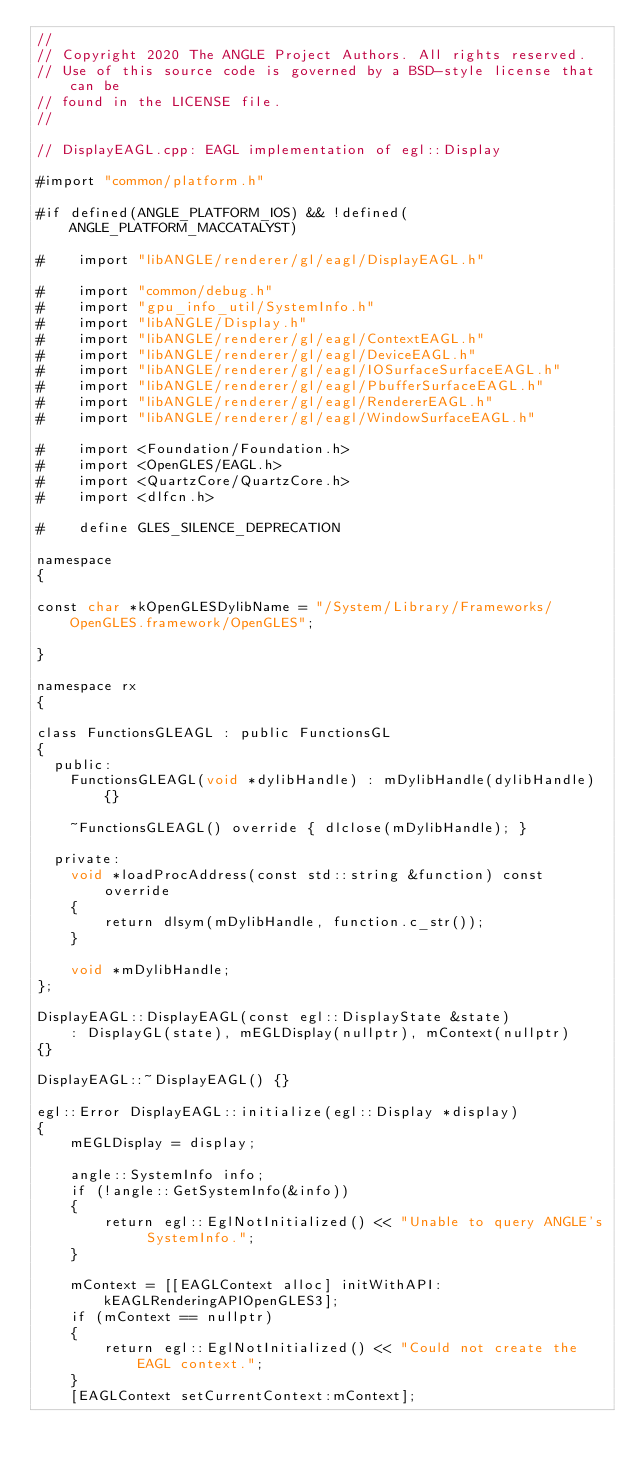<code> <loc_0><loc_0><loc_500><loc_500><_ObjectiveC_>//
// Copyright 2020 The ANGLE Project Authors. All rights reserved.
// Use of this source code is governed by a BSD-style license that can be
// found in the LICENSE file.
//

// DisplayEAGL.cpp: EAGL implementation of egl::Display

#import "common/platform.h"

#if defined(ANGLE_PLATFORM_IOS) && !defined(ANGLE_PLATFORM_MACCATALYST)

#    import "libANGLE/renderer/gl/eagl/DisplayEAGL.h"

#    import "common/debug.h"
#    import "gpu_info_util/SystemInfo.h"
#    import "libANGLE/Display.h"
#    import "libANGLE/renderer/gl/eagl/ContextEAGL.h"
#    import "libANGLE/renderer/gl/eagl/DeviceEAGL.h"
#    import "libANGLE/renderer/gl/eagl/IOSurfaceSurfaceEAGL.h"
#    import "libANGLE/renderer/gl/eagl/PbufferSurfaceEAGL.h"
#    import "libANGLE/renderer/gl/eagl/RendererEAGL.h"
#    import "libANGLE/renderer/gl/eagl/WindowSurfaceEAGL.h"

#    import <Foundation/Foundation.h>
#    import <OpenGLES/EAGL.h>
#    import <QuartzCore/QuartzCore.h>
#    import <dlfcn.h>

#    define GLES_SILENCE_DEPRECATION

namespace
{

const char *kOpenGLESDylibName = "/System/Library/Frameworks/OpenGLES.framework/OpenGLES";

}

namespace rx
{

class FunctionsGLEAGL : public FunctionsGL
{
  public:
    FunctionsGLEAGL(void *dylibHandle) : mDylibHandle(dylibHandle) {}

    ~FunctionsGLEAGL() override { dlclose(mDylibHandle); }

  private:
    void *loadProcAddress(const std::string &function) const override
    {
        return dlsym(mDylibHandle, function.c_str());
    }

    void *mDylibHandle;
};

DisplayEAGL::DisplayEAGL(const egl::DisplayState &state)
    : DisplayGL(state), mEGLDisplay(nullptr), mContext(nullptr)
{}

DisplayEAGL::~DisplayEAGL() {}

egl::Error DisplayEAGL::initialize(egl::Display *display)
{
    mEGLDisplay = display;

    angle::SystemInfo info;
    if (!angle::GetSystemInfo(&info))
    {
        return egl::EglNotInitialized() << "Unable to query ANGLE's SystemInfo.";
    }

    mContext = [[EAGLContext alloc] initWithAPI:kEAGLRenderingAPIOpenGLES3];
    if (mContext == nullptr)
    {
        return egl::EglNotInitialized() << "Could not create the EAGL context.";
    }
    [EAGLContext setCurrentContext:mContext];
</code> 